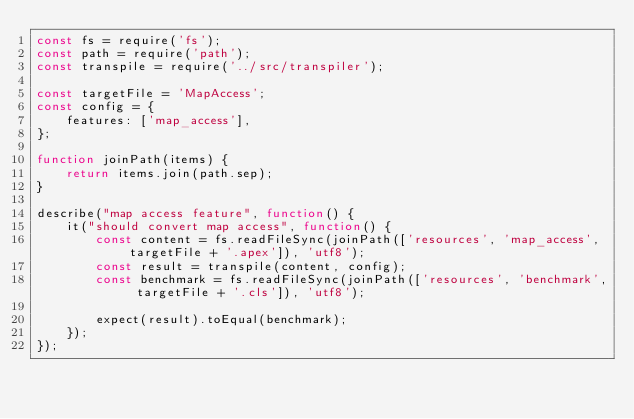<code> <loc_0><loc_0><loc_500><loc_500><_JavaScript_>const fs = require('fs');
const path = require('path');
const transpile = require('../src/transpiler');

const targetFile = 'MapAccess';
const config = {
    features: ['map_access'],
};

function joinPath(items) {
    return items.join(path.sep);
}

describe("map access feature", function() {
    it("should convert map access", function() {
        const content = fs.readFileSync(joinPath(['resources', 'map_access', targetFile + '.apex']), 'utf8');
        const result = transpile(content, config);
        const benchmark = fs.readFileSync(joinPath(['resources', 'benchmark', targetFile + '.cls']), 'utf8');

        expect(result).toEqual(benchmark);
    });
});
</code> 